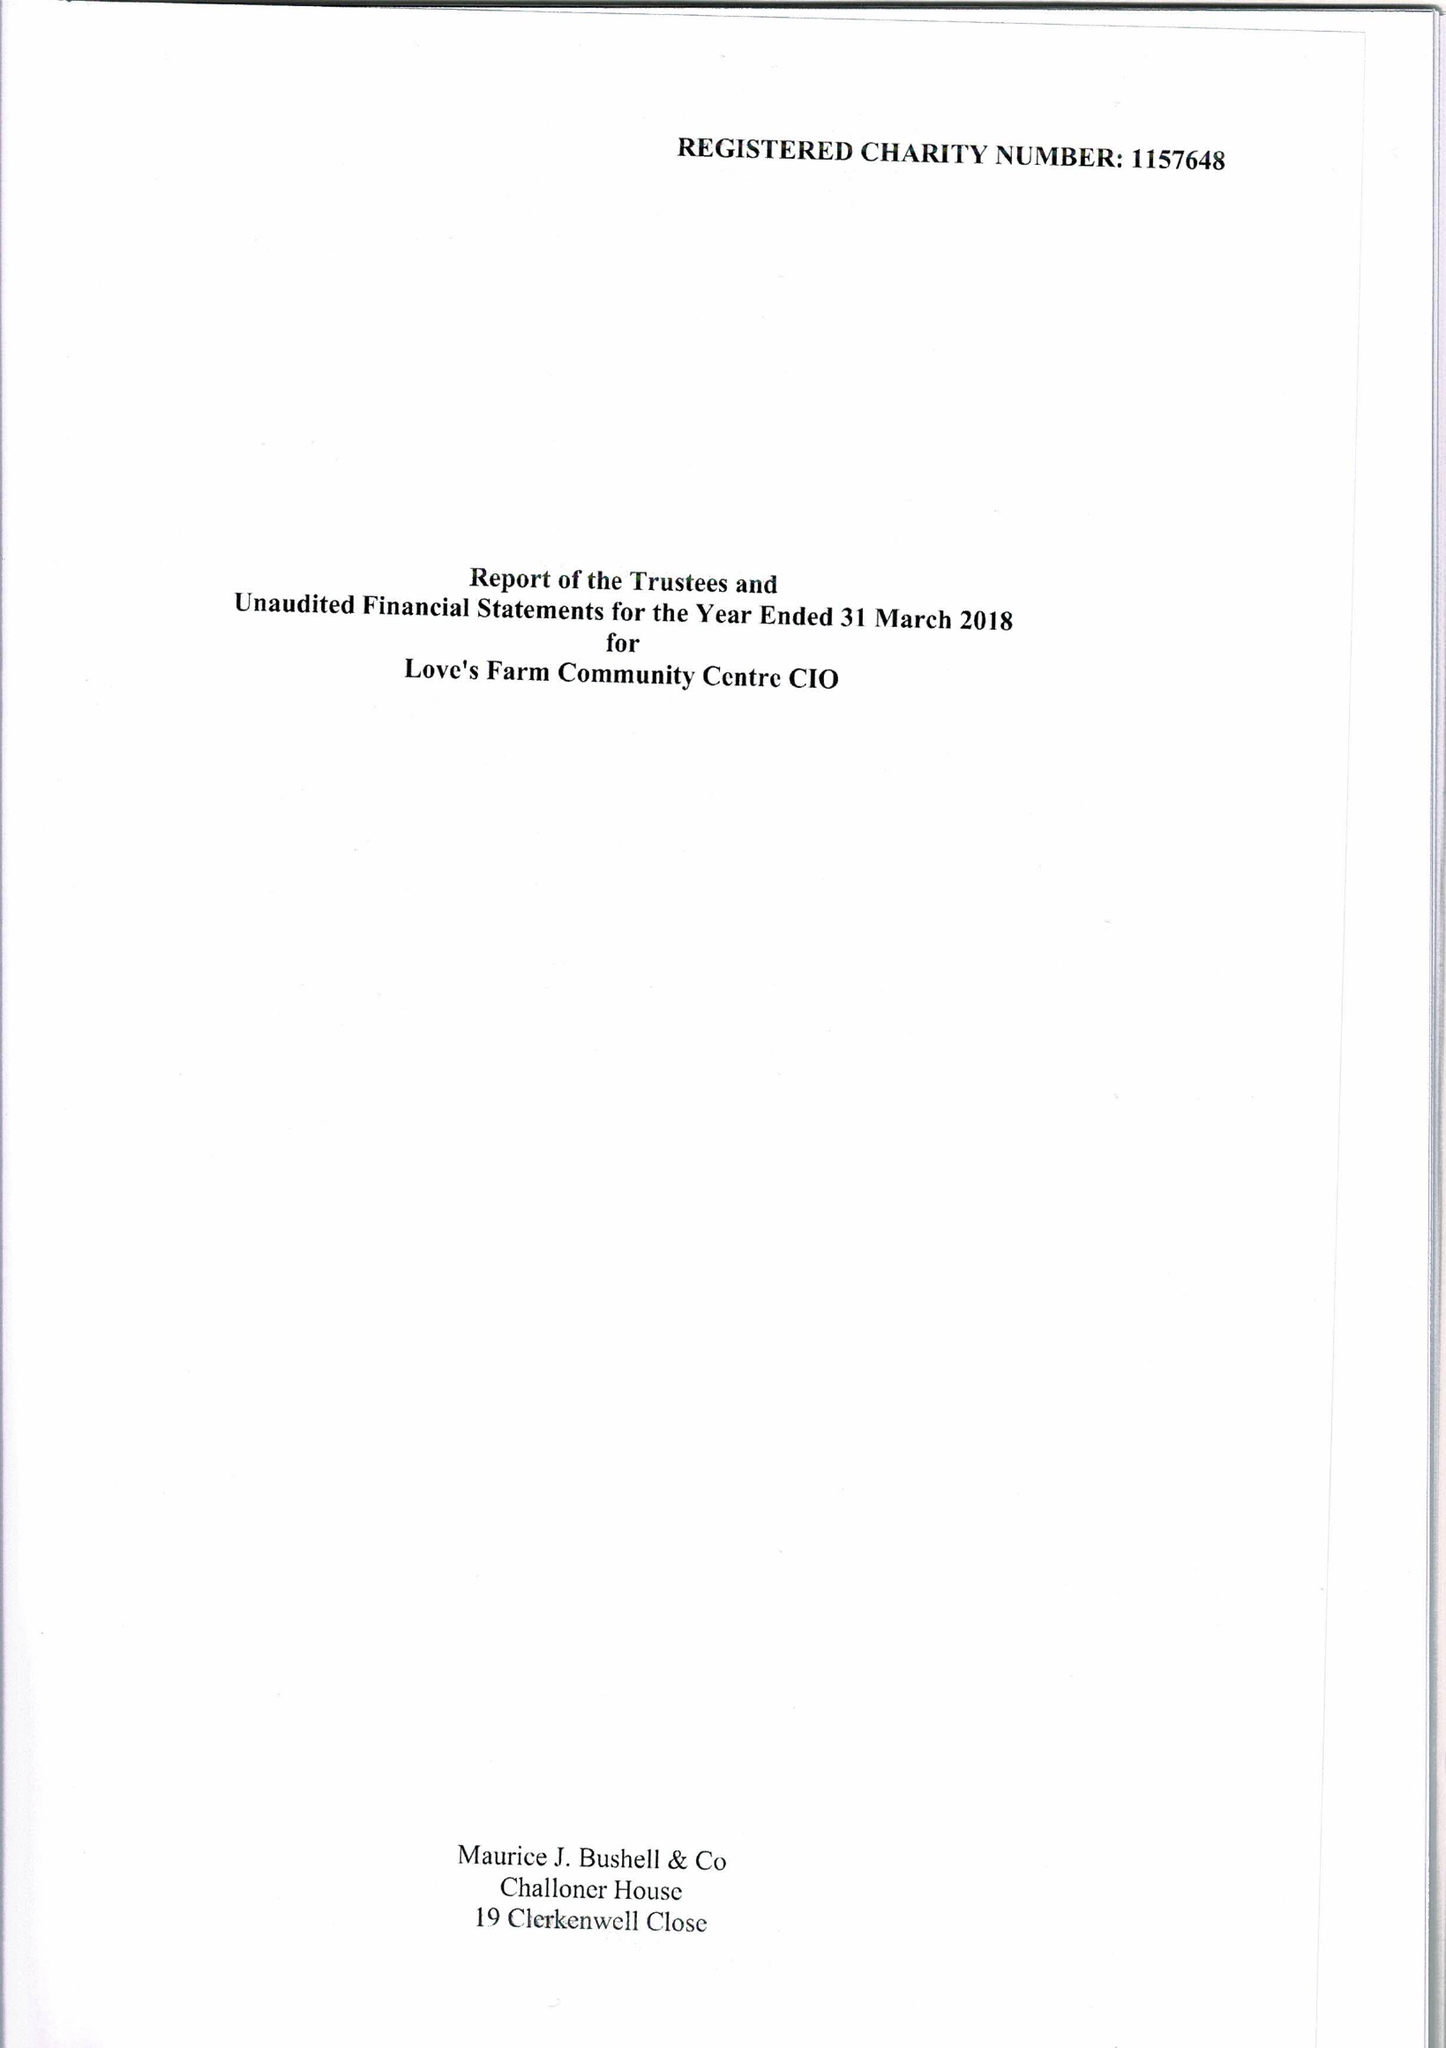What is the value for the address__street_line?
Answer the question using a single word or phrase. 17 KESTER WAY 